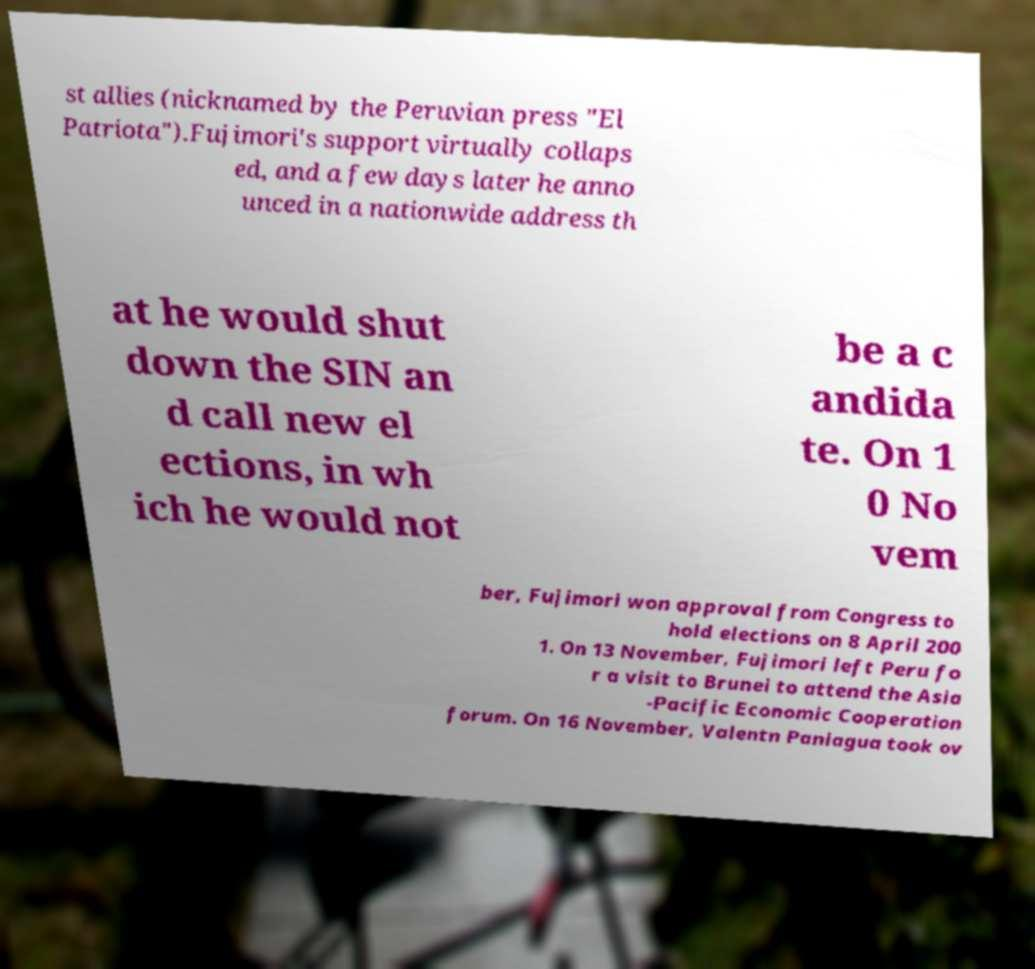Can you read and provide the text displayed in the image?This photo seems to have some interesting text. Can you extract and type it out for me? st allies (nicknamed by the Peruvian press "El Patriota").Fujimori's support virtually collaps ed, and a few days later he anno unced in a nationwide address th at he would shut down the SIN an d call new el ections, in wh ich he would not be a c andida te. On 1 0 No vem ber, Fujimori won approval from Congress to hold elections on 8 April 200 1. On 13 November, Fujimori left Peru fo r a visit to Brunei to attend the Asia -Pacific Economic Cooperation forum. On 16 November, Valentn Paniagua took ov 